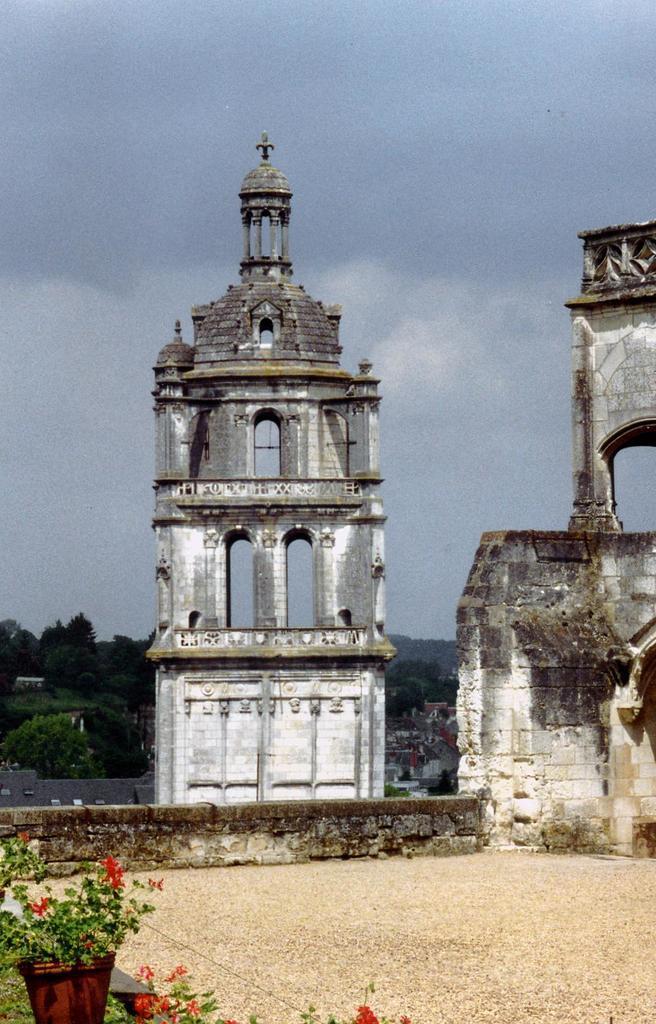How would you summarize this image in a sentence or two? In this image I can see towers and flower pots and the sky 